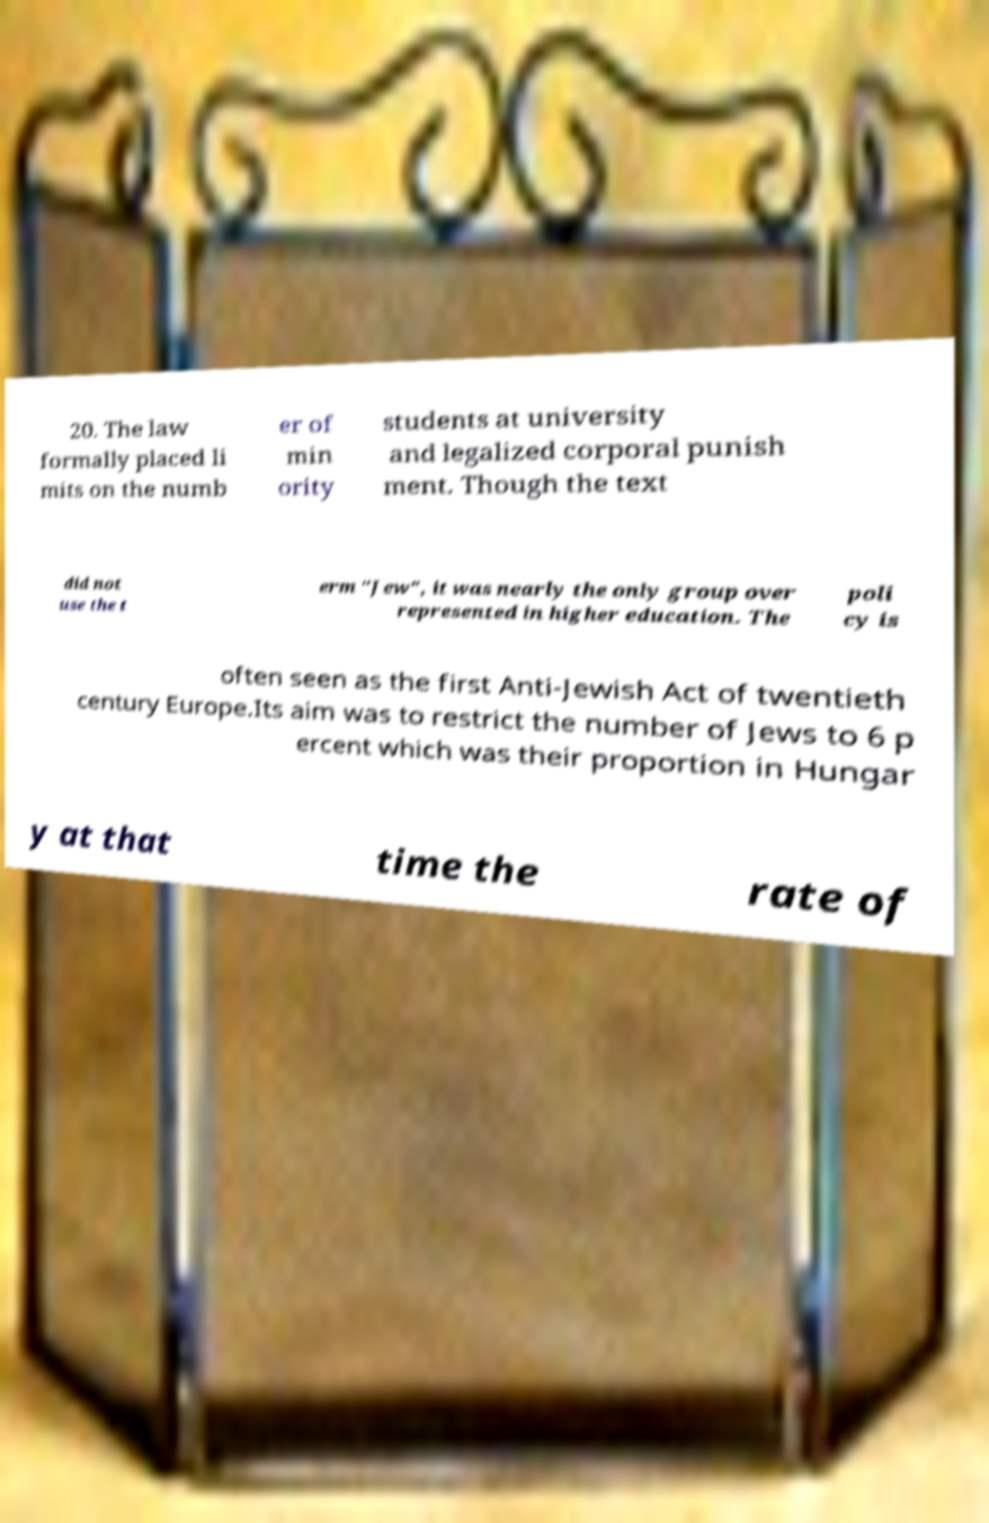Please read and relay the text visible in this image. What does it say? 20. The law formally placed li mits on the numb er of min ority students at university and legalized corporal punish ment. Though the text did not use the t erm "Jew", it was nearly the only group over represented in higher education. The poli cy is often seen as the first Anti-Jewish Act of twentieth century Europe.Its aim was to restrict the number of Jews to 6 p ercent which was their proportion in Hungar y at that time the rate of 